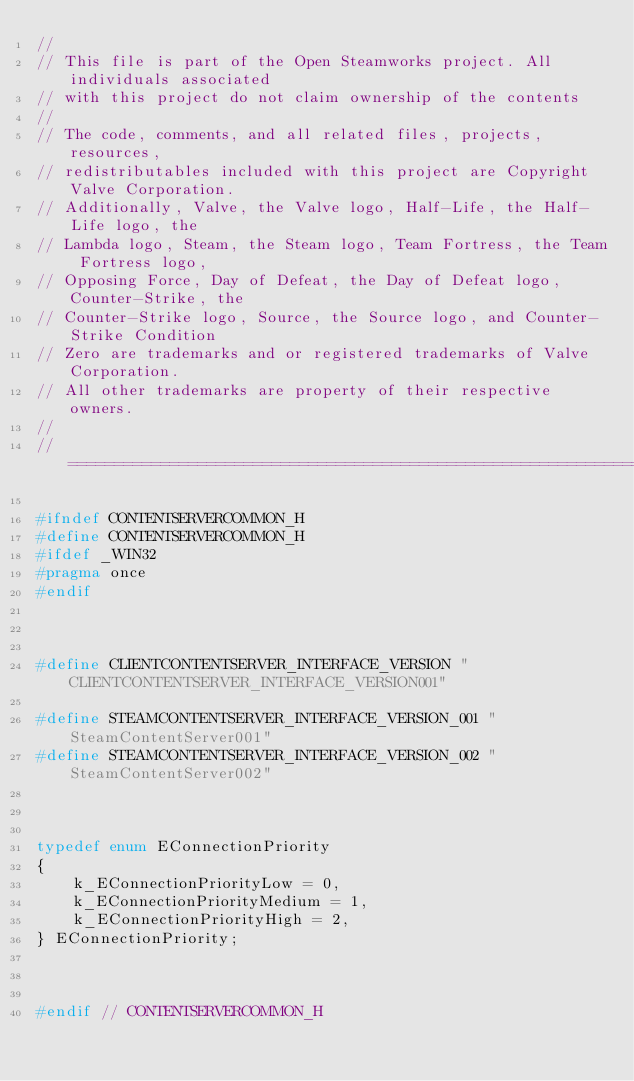<code> <loc_0><loc_0><loc_500><loc_500><_C_>//
// This file is part of the Open Steamworks project. All individuals associated
// with this project do not claim ownership of the contents
// 
// The code, comments, and all related files, projects, resources,
// redistributables included with this project are Copyright Valve Corporation.
// Additionally, Valve, the Valve logo, Half-Life, the Half-Life logo, the
// Lambda logo, Steam, the Steam logo, Team Fortress, the Team Fortress logo,
// Opposing Force, Day of Defeat, the Day of Defeat logo, Counter-Strike, the
// Counter-Strike logo, Source, the Source logo, and Counter-Strike Condition
// Zero are trademarks and or registered trademarks of Valve Corporation.
// All other trademarks are property of their respective owners.
//
//=============================================================================

#ifndef CONTENTSERVERCOMMON_H
#define CONTENTSERVERCOMMON_H
#ifdef _WIN32
#pragma once
#endif



#define CLIENTCONTENTSERVER_INTERFACE_VERSION "CLIENTCONTENTSERVER_INTERFACE_VERSION001"

#define STEAMCONTENTSERVER_INTERFACE_VERSION_001 "SteamContentServer001"
#define STEAMCONTENTSERVER_INTERFACE_VERSION_002 "SteamContentServer002"



typedef enum EConnectionPriority
{
	k_EConnectionPriorityLow = 0,
	k_EConnectionPriorityMedium = 1,
	k_EConnectionPriorityHigh = 2,
} EConnectionPriority;



#endif // CONTENTSERVERCOMMON_H
</code> 